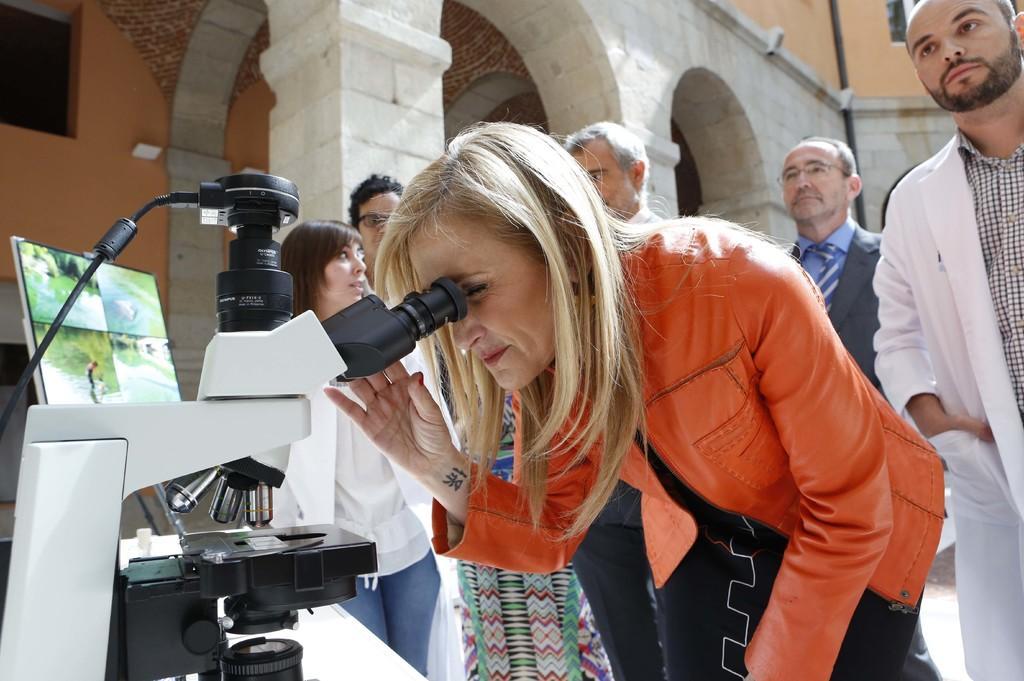Could you give a brief overview of what you see in this image? In this image we can see people, microscope, and a screen. In the background we can see wall, arches, pillars, and a pole. 